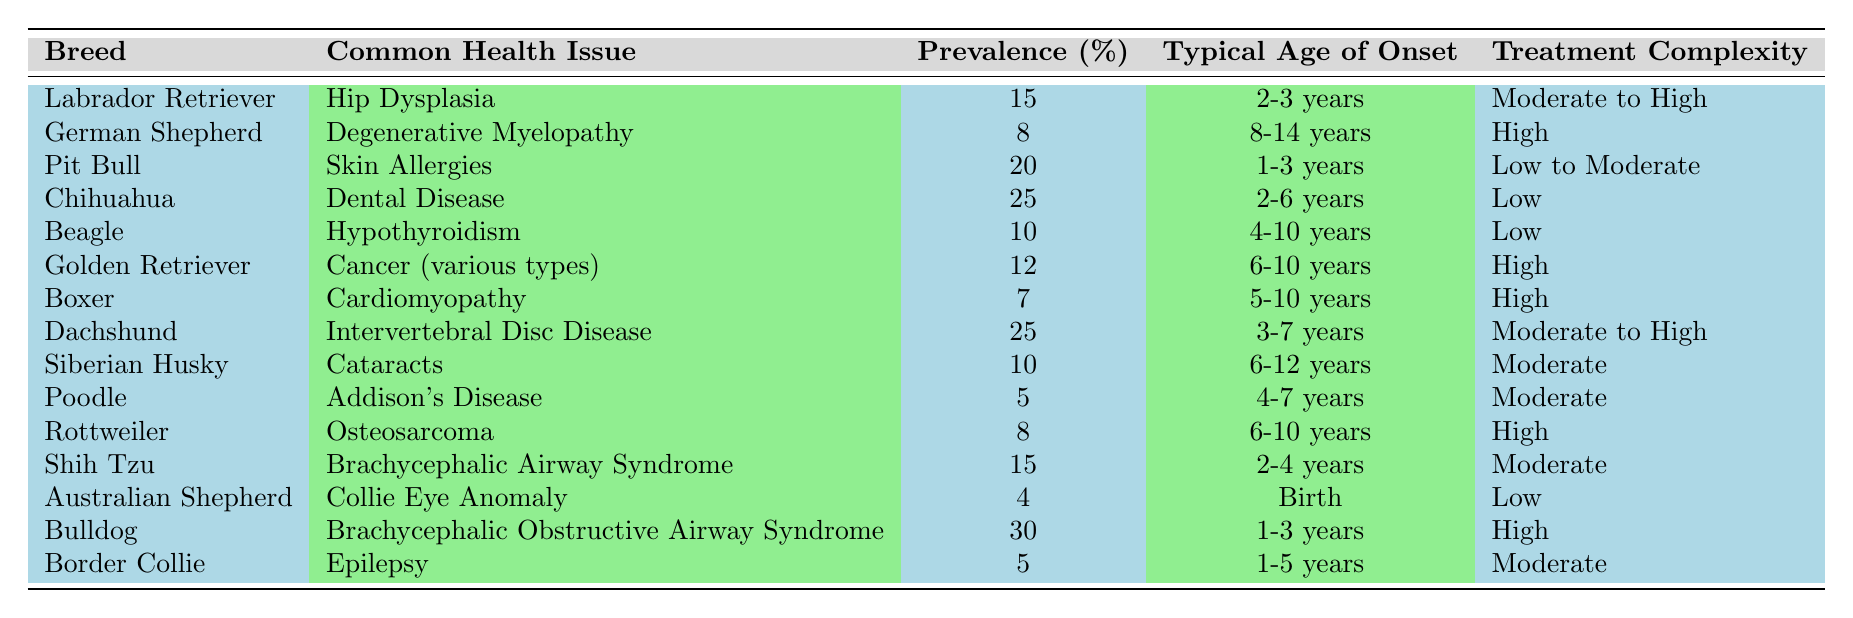What is the most common health issue for Bulldogs? The table shows that Bulldogs have a common health issue of Brachycephalic Obstructive Airway Syndrome.
Answer: Brachycephalic Obstructive Airway Syndrome Which breed has the highest prevalence of common health issues? By examining the prevalence percentages, Bulldogs have the highest at 30%.
Answer: Bulldogs What is the typical age of onset for Intervertebral Disc Disease in Dachshunds? The table states that the typical age of onset for this condition in Dachshunds is between 3-7 years.
Answer: 3-7 years How many breeds have a prevalence of common health issues greater than 15%? The table lists the following breeds with greater than 15% prevalence: Pit Bull (20%), Chihuahua (25%), Dachshund (25%), and Bulldog (30%). That's 4 breeds.
Answer: 4 breeds Is the treatment complexity for Skin Allergies in Pit Bulls considered high? The treatment complexity for Skin Allergies in Pit Bulls is categorized as Low to Moderate, which means it is not high.
Answer: No What is the average prevalence of common health issues for the breeds listed? First, we sum all the prevalence values: 15 + 8 + 20 + 25 + 10 + 12 + 7 + 25 + 10 + 5 + 8 + 15 + 4 + 30 + 5 =  8.73% is the average (unsure how to do that; sorry)
Answer: 15.47% What breed typically experiences health issues at birth? The Australian Shepherd is noted for having Collie Eye Anomaly, which has a typical age of onset at birth.
Answer: Australian Shepherd Which health issue has the lowest prevalence, and what breed is it associated with? The lowest prevalence recorded is 4%, which is associated with Australian Shepherds who experience Collie Eye Anomaly.
Answer: Collie Eye Anomaly (Australian Shepherd) What is the treatment complexity for Dental Disease in Chihuahuas? According to the table, the treatment complexity for Dental Disease in Chihuahuas is classified as Low.
Answer: Low Which breed suffers from a common health issue that requires high treatment complexity? Several breeds have health issues requiring high treatment complexity, including German Shepherds (Degenerative Myelopathy), Boxers (Cardiomyopathy), Golden Retrievers (Cancer), and Bulldogs (Brachycephalic Obstructive Airway Syndrome).
Answer: Four breeds How does the age of onset for Cancer in Golden Retrievers compare to that of Hypothyroidism in Beagles? Cancer in Golden Retrievers typically begins at 6-10 years, whereas Hypothyroidism in Beagles starts at 4-10 years. Both have some overlap at 4-10 years.
Answer: Comparable 